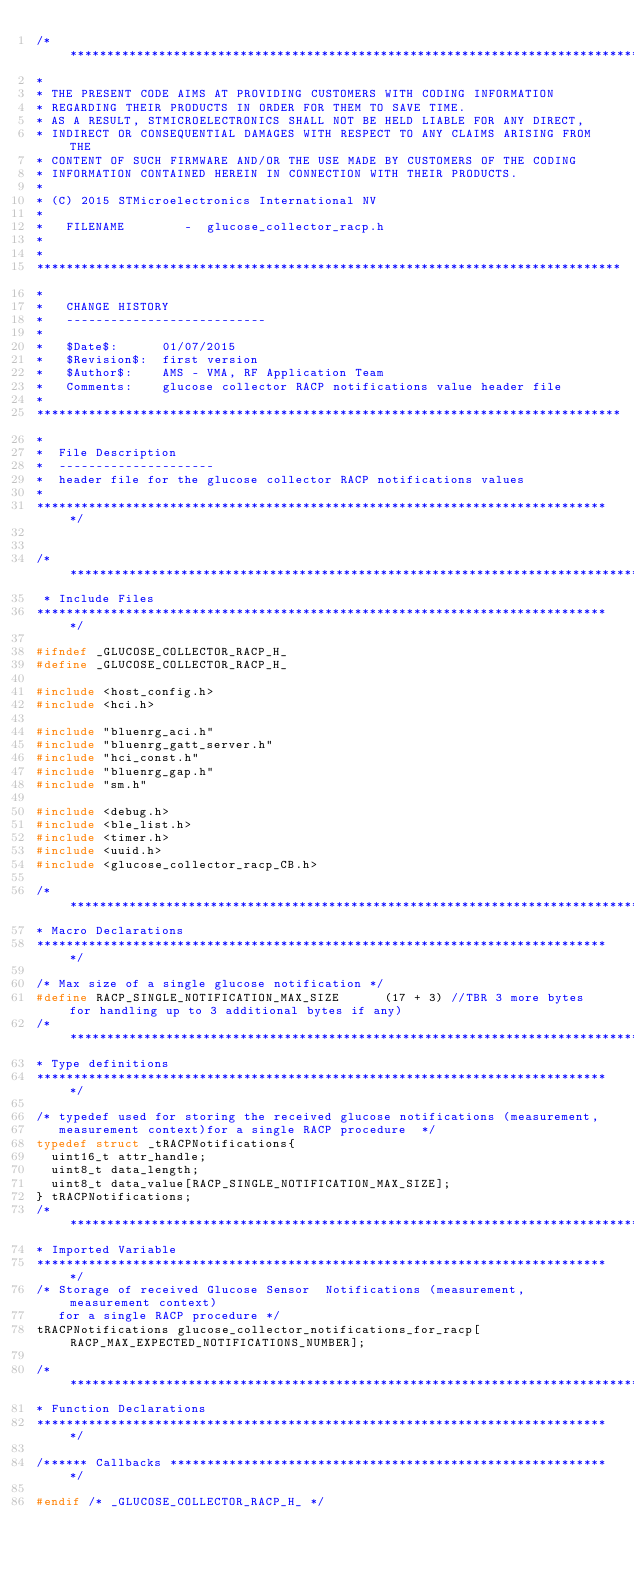Convert code to text. <code><loc_0><loc_0><loc_500><loc_500><_C_>/******************************************************************************
*
* THE PRESENT CODE AIMS AT PROVIDING CUSTOMERS WITH CODING INFORMATION
* REGARDING THEIR PRODUCTS IN ORDER FOR THEM TO SAVE TIME.
* AS A RESULT, STMICROELECTRONICS SHALL NOT BE HELD LIABLE FOR ANY DIRECT,
* INDIRECT OR CONSEQUENTIAL DAMAGES WITH RESPECT TO ANY CLAIMS ARISING FROM THE
* CONTENT OF SUCH FIRMWARE AND/OR THE USE MADE BY CUSTOMERS OF THE CODING
* INFORMATION CONTAINED HEREIN IN CONNECTION WITH THEIR PRODUCTS.
*
* (C) 2015 STMicroelectronics International NV
*
*   FILENAME        -  glucose_collector_racp.h
*
*
*******************************************************************************
*
*   CHANGE HISTORY
*   ---------------------------
*
*   $Date$:      01/07/2015
*   $Revision$:  first version
*   $Author$:    AMS - VMA, RF Application Team
*   Comments:    glucose collector RACP notifications value header file 
*
*******************************************************************************
*
*  File Description 
*  ---------------------
*  header file for the glucose collector RACP notifications values
* 
******************************************************************************/


/******************************************************************************
 * Include Files
******************************************************************************/

#ifndef _GLUCOSE_COLLECTOR_RACP_H_
#define _GLUCOSE_COLLECTOR_RACP_H_

#include <host_config.h>
#include <hci.h>

#include "bluenrg_aci.h"
#include "bluenrg_gatt_server.h"
#include "hci_const.h"
#include "bluenrg_gap.h"
#include "sm.h"

#include <debug.h>
#include <ble_list.h>
#include <timer.h>
#include <uuid.h>
#include <glucose_collector_racp_CB.h>

/******************************************************************************
* Macro Declarations
******************************************************************************/

/* Max size of a single glucose notification */
#define RACP_SINGLE_NOTIFICATION_MAX_SIZE      (17 + 3) //TBR 3 more bytes for handling up to 3 additional bytes if any)
/******************************************************************************
* Type definitions
******************************************************************************/

/* typedef used for storing the received glucose notifications (measurement, 
   measurement context)for a single RACP procedure  */
typedef struct _tRACPNotifications{
  uint16_t attr_handle; 
  uint8_t data_length; 
  uint8_t data_value[RACP_SINGLE_NOTIFICATION_MAX_SIZE]; 
} tRACPNotifications;
/******************************************************************************
* Imported Variable
******************************************************************************/
/* Storage of received Glucose Sensor  Notifications (measurement, measurement context) 
   for a single RACP procedure */
tRACPNotifications glucose_collector_notifications_for_racp[RACP_MAX_EXPECTED_NOTIFICATIONS_NUMBER];

/******************************************************************************
* Function Declarations
******************************************************************************/

/****** Callbacks ************************************************************/

#endif /* _GLUCOSE_COLLECTOR_RACP_H_ */
</code> 